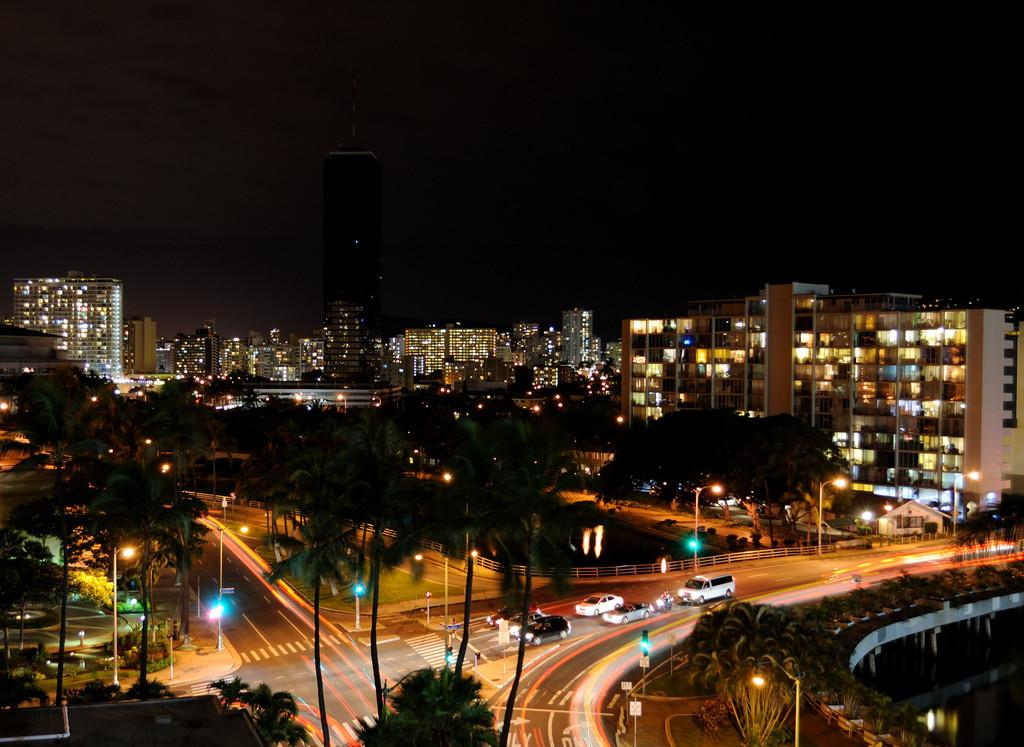What type of structures can be seen in the image? There are buildings in the image. What other natural elements are present in the image? There are trees in the image. What type of transportation infrastructure is visible in the image? There are roads in the image. What are the vehicles in the image used for? The vehicles in the image are used for transportation. What type of illumination is present in the image? There are lights in the image. What type of signage is present in the image? There are boards in the image. What can be seen in the background of the image? The sky is visible in the background of the image. Where is the faucet located in the image? There is no faucet present in the image. What type of spacecraft can be seen in the image? There are no spacecraft present in the image; it features buildings, trees, roads, vehicles, lights, boards, and the sky. 